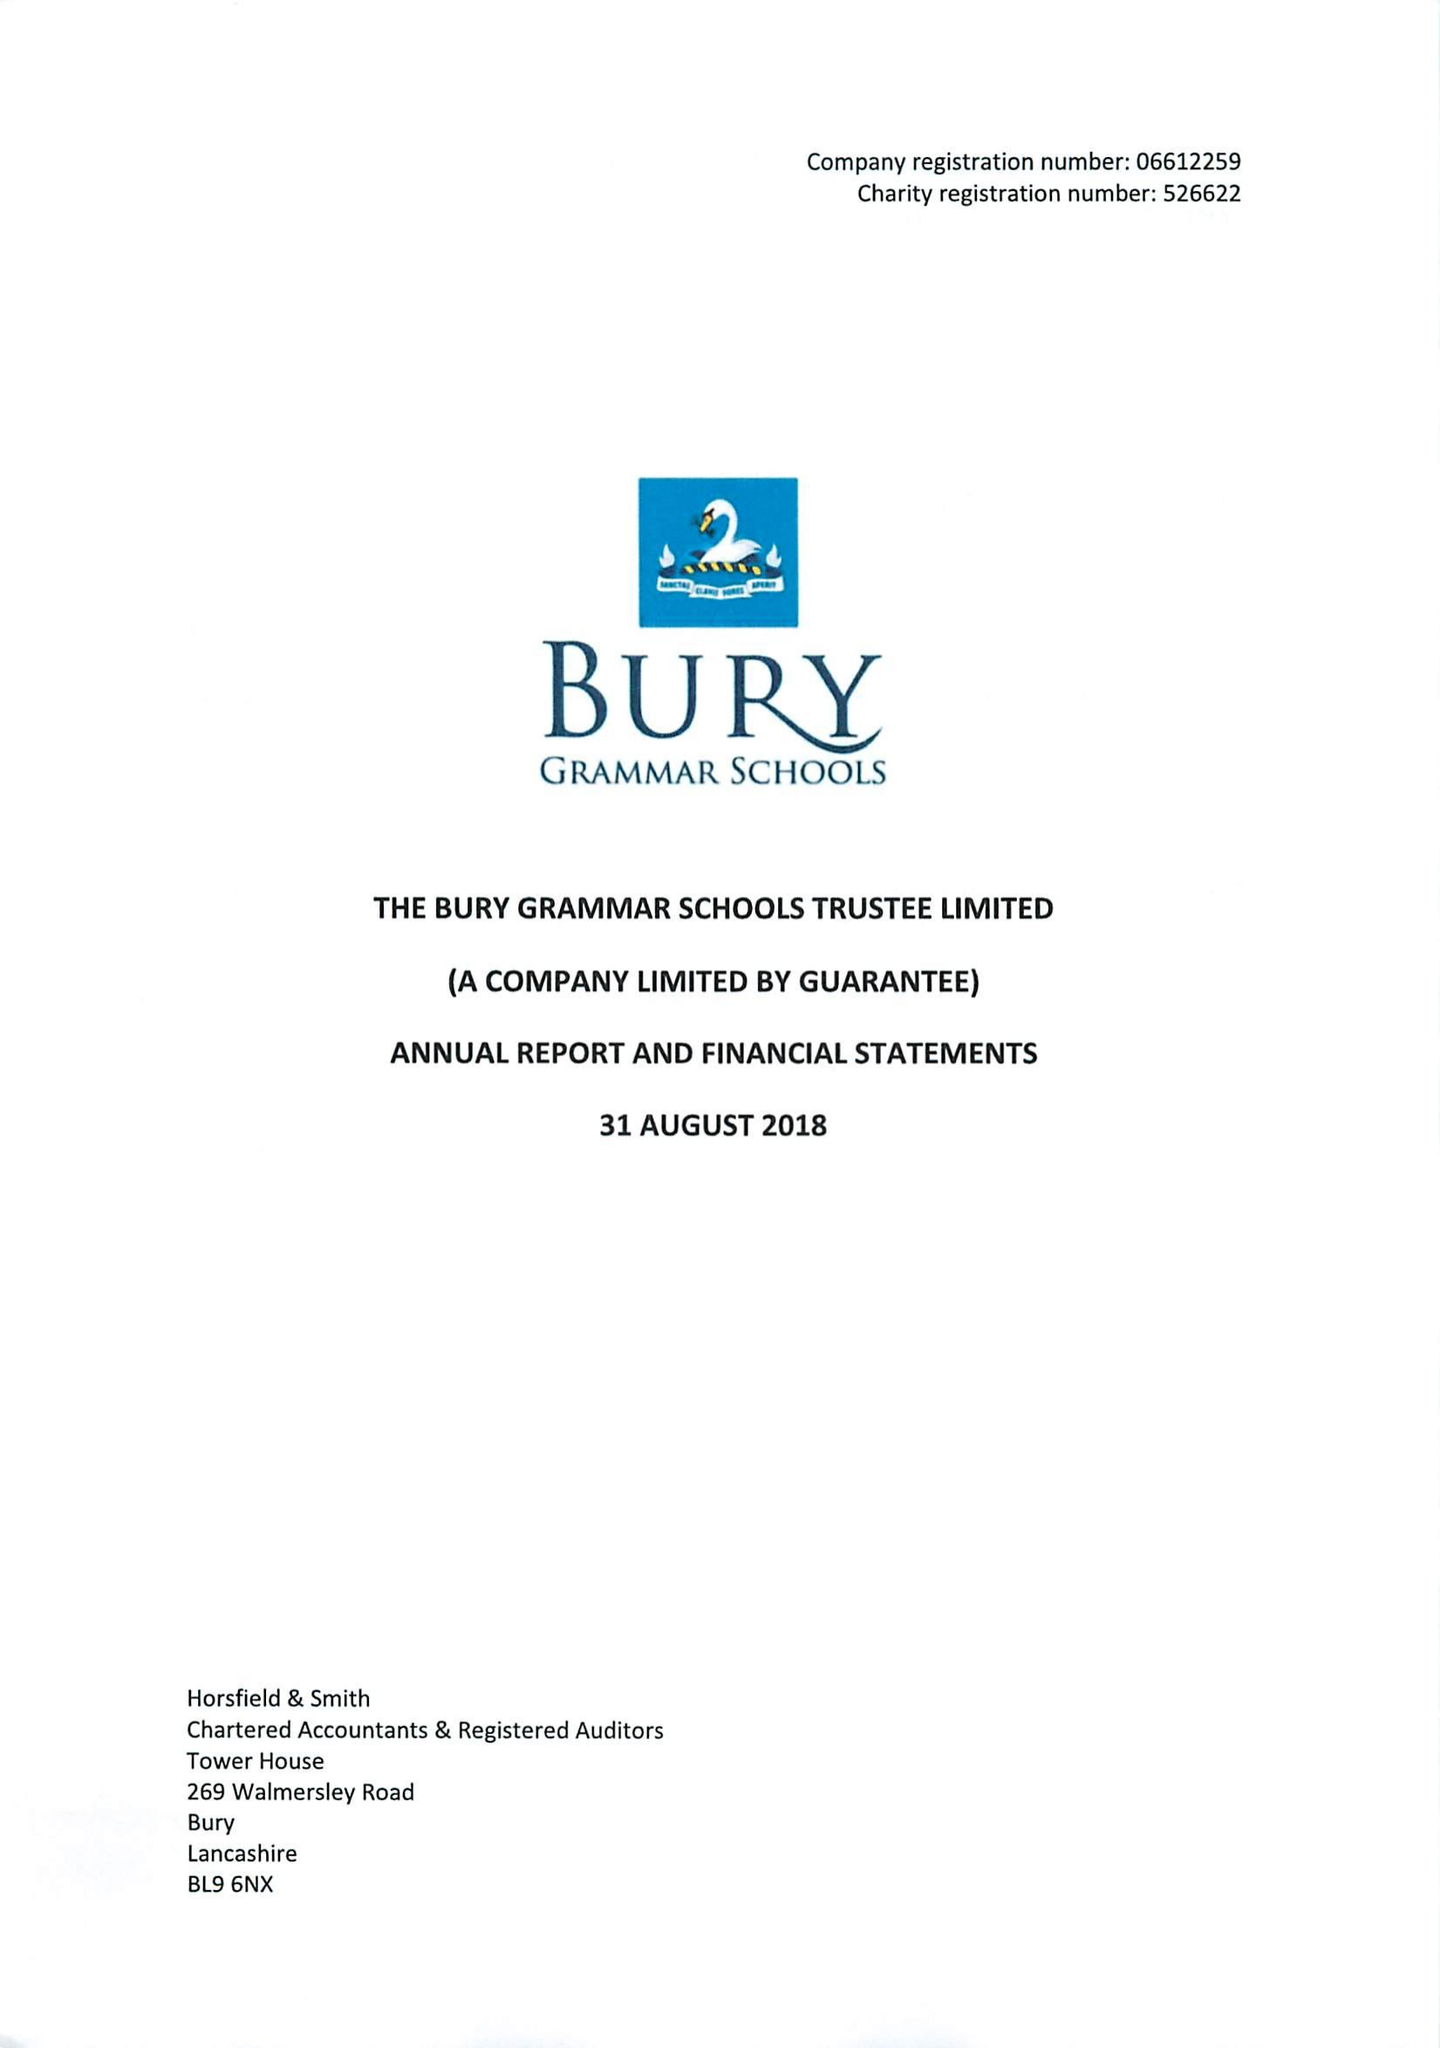What is the value for the charity_name?
Answer the question using a single word or phrase. Bury Grammar Schools Trustee Ltd. 